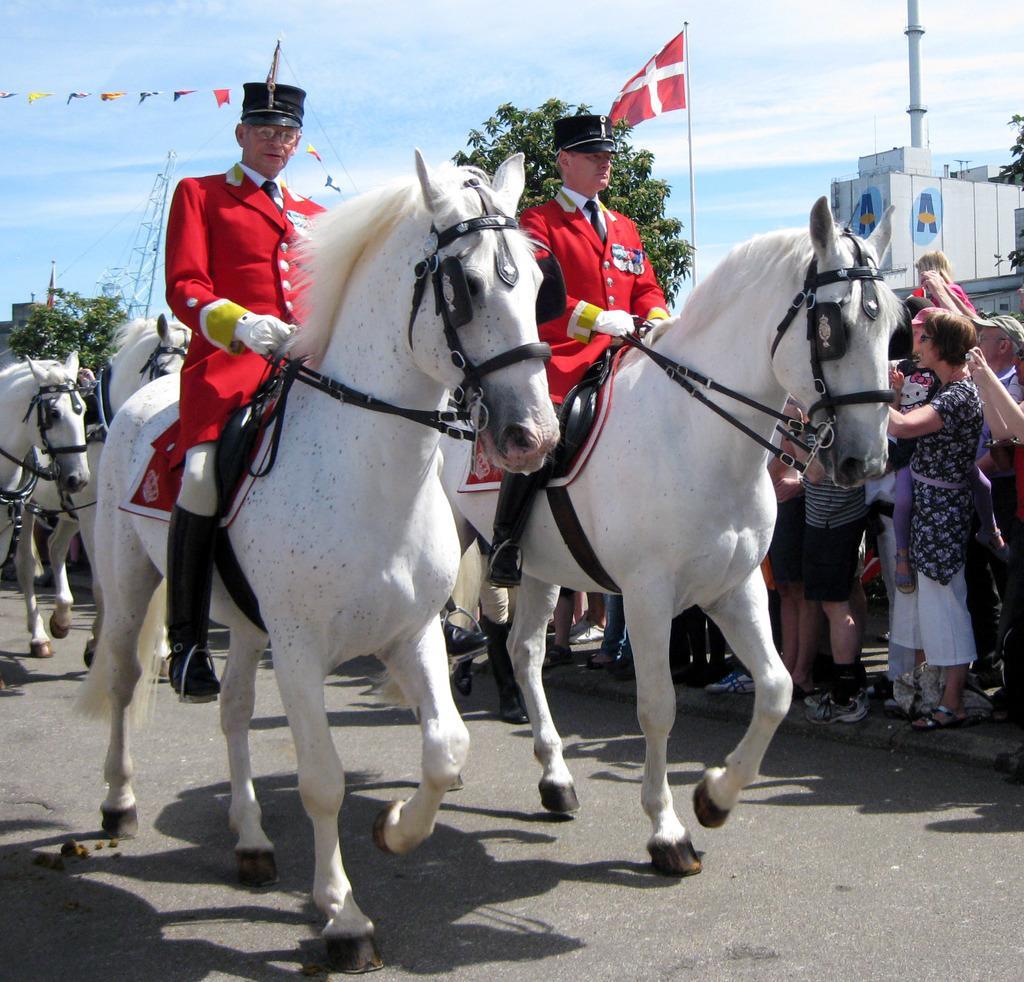In one or two sentences, can you explain what this image depicts? In this image I can see two people are sitting on white horses. These people are wearing red color dresses and hats. In the background I can see trees, people are standing, a flag, and pole, horses and the sky. 